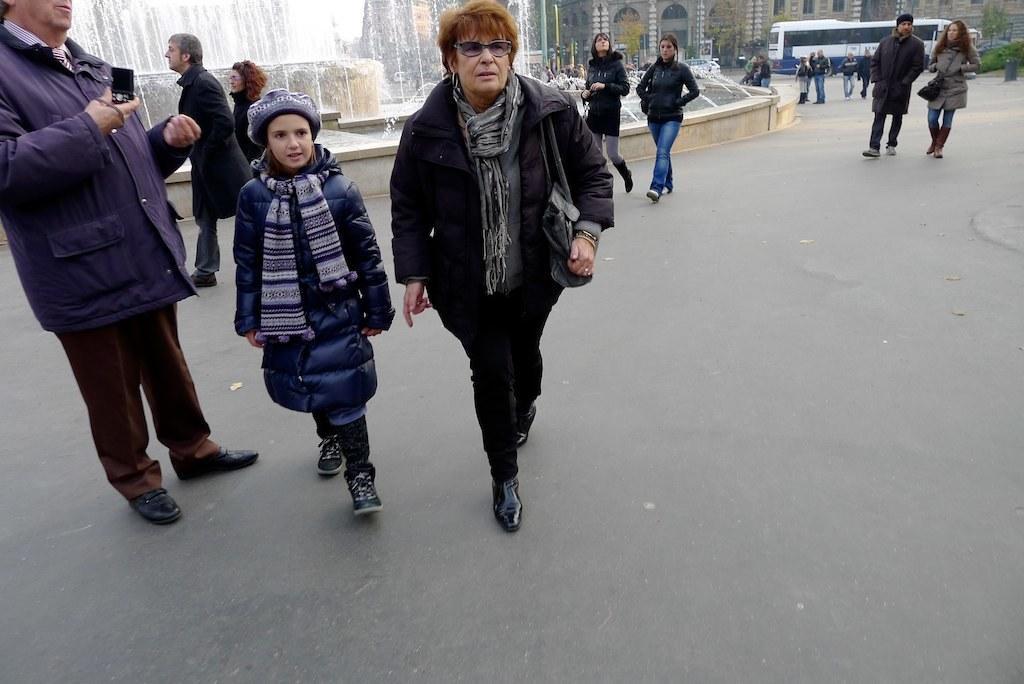Describe this image in one or two sentences. This image consists of many people. And we can see the people walking on the road. At the bottom, there is a road. On the left, we can see a fountain. On the right, there is a bus along with buildings. 